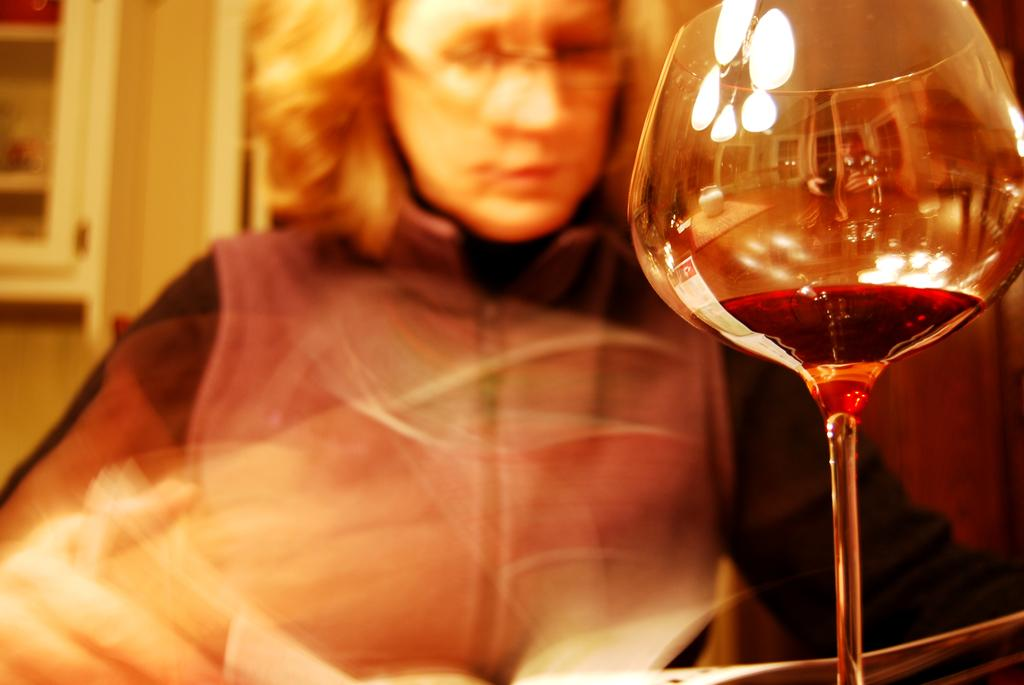What is the woman in the image doing? The woman is sitting in the image and holding a book. What else can be seen on the table in the image? There is a glass on the table in the image. What is inside the glass? There is liquid in the glass. How would you describe the overall quality of the image? The image appears blurry. What type of creature is depicted on the canvas in the image? There is no canvas or creature present in the image. 